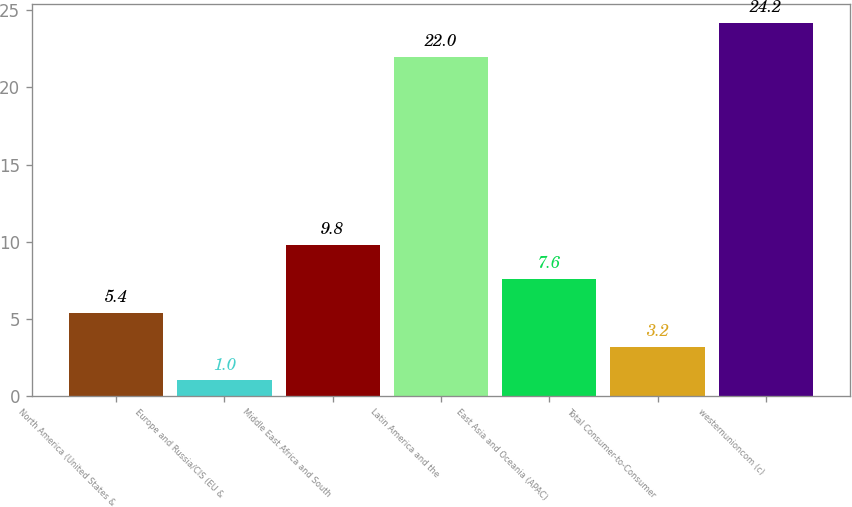<chart> <loc_0><loc_0><loc_500><loc_500><bar_chart><fcel>North America (United States &<fcel>Europe and Russia/CIS (EU &<fcel>Middle East Africa and South<fcel>Latin America and the<fcel>East Asia and Oceania (APAC)<fcel>Total Consumer-to-Consumer<fcel>westernunioncom (c)<nl><fcel>5.4<fcel>1<fcel>9.8<fcel>22<fcel>7.6<fcel>3.2<fcel>24.2<nl></chart> 